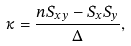<formula> <loc_0><loc_0><loc_500><loc_500>\kappa = \frac { n S _ { x y } - S _ { x } S _ { y } } { \Delta } ,</formula> 